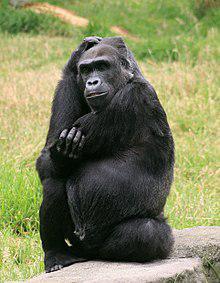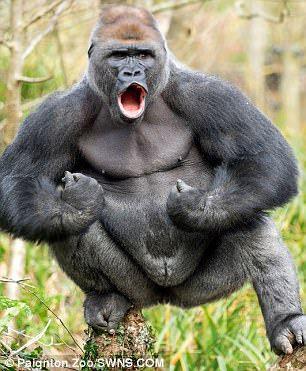The first image is the image on the left, the second image is the image on the right. Evaluate the accuracy of this statement regarding the images: "A baby gorilla is with an adult gorilla in at least one of the images.". Is it true? Answer yes or no. No. The first image is the image on the left, the second image is the image on the right. Given the left and right images, does the statement "Two of the apes are posed in contact and face to face, but neither is held off the ground by the other." hold true? Answer yes or no. No. 